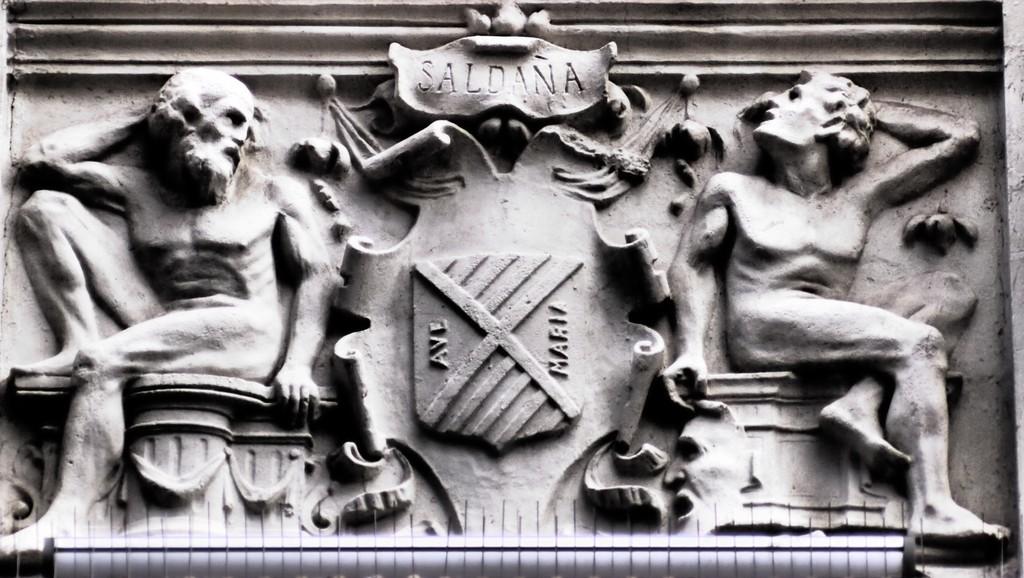Which country could this be from?
Give a very brief answer. Saldana. What avenue is mentioned?
Your answer should be compact. Maria. 